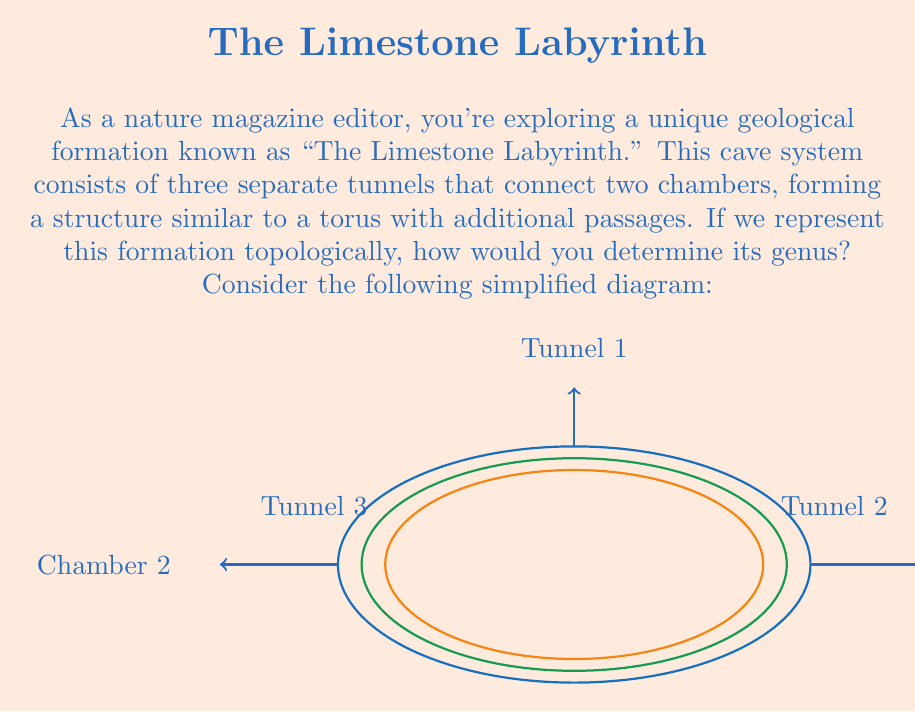Help me with this question. To determine the genus of this geological formation, we need to follow these steps:

1) First, recall that the genus of a surface is the maximum number of simple closed curves that can be drawn on the surface without separating it.

2) In this case, we have a structure that resembles a torus (donut shape) with additional tunnels. A standard torus has a genus of 1.

3) Let's count the number of additional "handles" formed by the tunnels:
   - Tunnel 1 forms one additional handle
   - Tunnel 2 forms another additional handle
   - Tunnel 3 forms yet another additional handle

4) Each of these tunnels adds 1 to the genus of the surface. We can think of each tunnel as creating a new "hole" in the surface.

5) Therefore, we can calculate the genus as follows:
   $$\text{Genus} = \text{Genus of torus} + \text{Number of additional tunnels}$$
   $$\text{Genus} = 1 + 3 = 4$$

6) We can verify this by considering that we can draw 4 simple closed curves on this surface without separating it:
   - One around the main body of the torus
   - One through each of the three additional tunnels

7) The Euler characteristic $\chi$ of a surface is related to its genus $g$ by the formula:
   $$\chi = 2 - 2g$$
   
   For our surface with genus 4, the Euler characteristic would be:
   $$\chi = 2 - 2(4) = -6$$

This negative Euler characteristic is consistent with a complex, multi-holed surface.
Answer: $4$ 